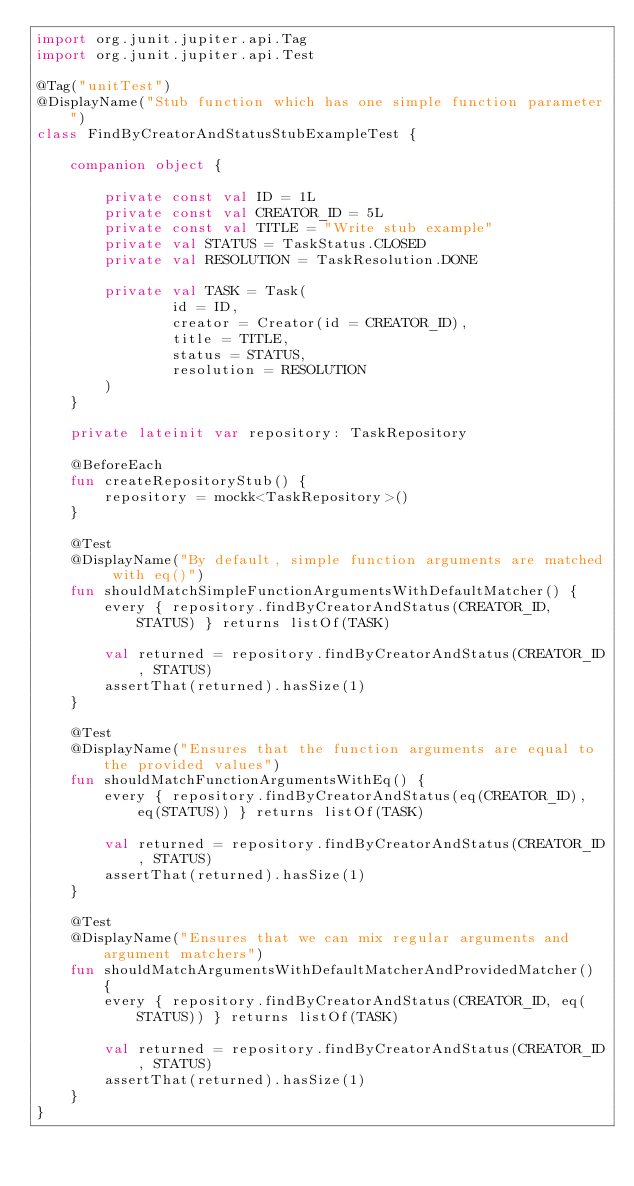<code> <loc_0><loc_0><loc_500><loc_500><_Kotlin_>import org.junit.jupiter.api.Tag
import org.junit.jupiter.api.Test

@Tag("unitTest")
@DisplayName("Stub function which has one simple function parameter")
class FindByCreatorAndStatusStubExampleTest {

    companion object {

        private const val ID = 1L
        private const val CREATOR_ID = 5L
        private const val TITLE = "Write stub example"
        private val STATUS = TaskStatus.CLOSED
        private val RESOLUTION = TaskResolution.DONE

        private val TASK = Task(
                id = ID,
                creator = Creator(id = CREATOR_ID),
                title = TITLE,
                status = STATUS,
                resolution = RESOLUTION
        )
    }

    private lateinit var repository: TaskRepository

    @BeforeEach
    fun createRepositoryStub() {
        repository = mockk<TaskRepository>()
    }

    @Test
    @DisplayName("By default, simple function arguments are matched with eq()")
    fun shouldMatchSimpleFunctionArgumentsWithDefaultMatcher() {
        every { repository.findByCreatorAndStatus(CREATOR_ID, STATUS) } returns listOf(TASK)

        val returned = repository.findByCreatorAndStatus(CREATOR_ID, STATUS)
        assertThat(returned).hasSize(1)
    }

    @Test
    @DisplayName("Ensures that the function arguments are equal to the provided values")
    fun shouldMatchFunctionArgumentsWithEq() {
        every { repository.findByCreatorAndStatus(eq(CREATOR_ID), eq(STATUS)) } returns listOf(TASK)

        val returned = repository.findByCreatorAndStatus(CREATOR_ID, STATUS)
        assertThat(returned).hasSize(1)
    }

    @Test
    @DisplayName("Ensures that we can mix regular arguments and argument matchers")
    fun shouldMatchArgumentsWithDefaultMatcherAndProvidedMatcher() {
        every { repository.findByCreatorAndStatus(CREATOR_ID, eq(STATUS)) } returns listOf(TASK)

        val returned = repository.findByCreatorAndStatus(CREATOR_ID, STATUS)
        assertThat(returned).hasSize(1)
    }
}</code> 